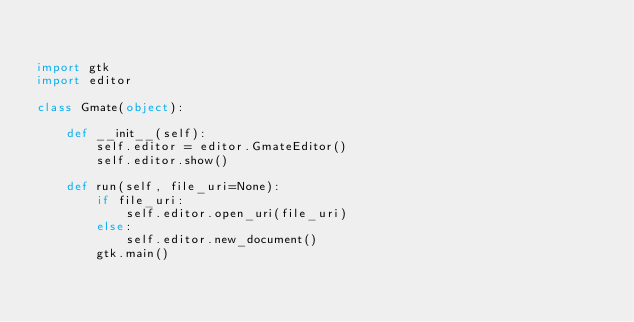<code> <loc_0><loc_0><loc_500><loc_500><_Python_>

import gtk
import editor

class Gmate(object):

    def __init__(self):
        self.editor = editor.GmateEditor()
        self.editor.show()

    def run(self, file_uri=None):
        if file_uri:
            self.editor.open_uri(file_uri)
        else:
            self.editor.new_document()
        gtk.main()

</code> 